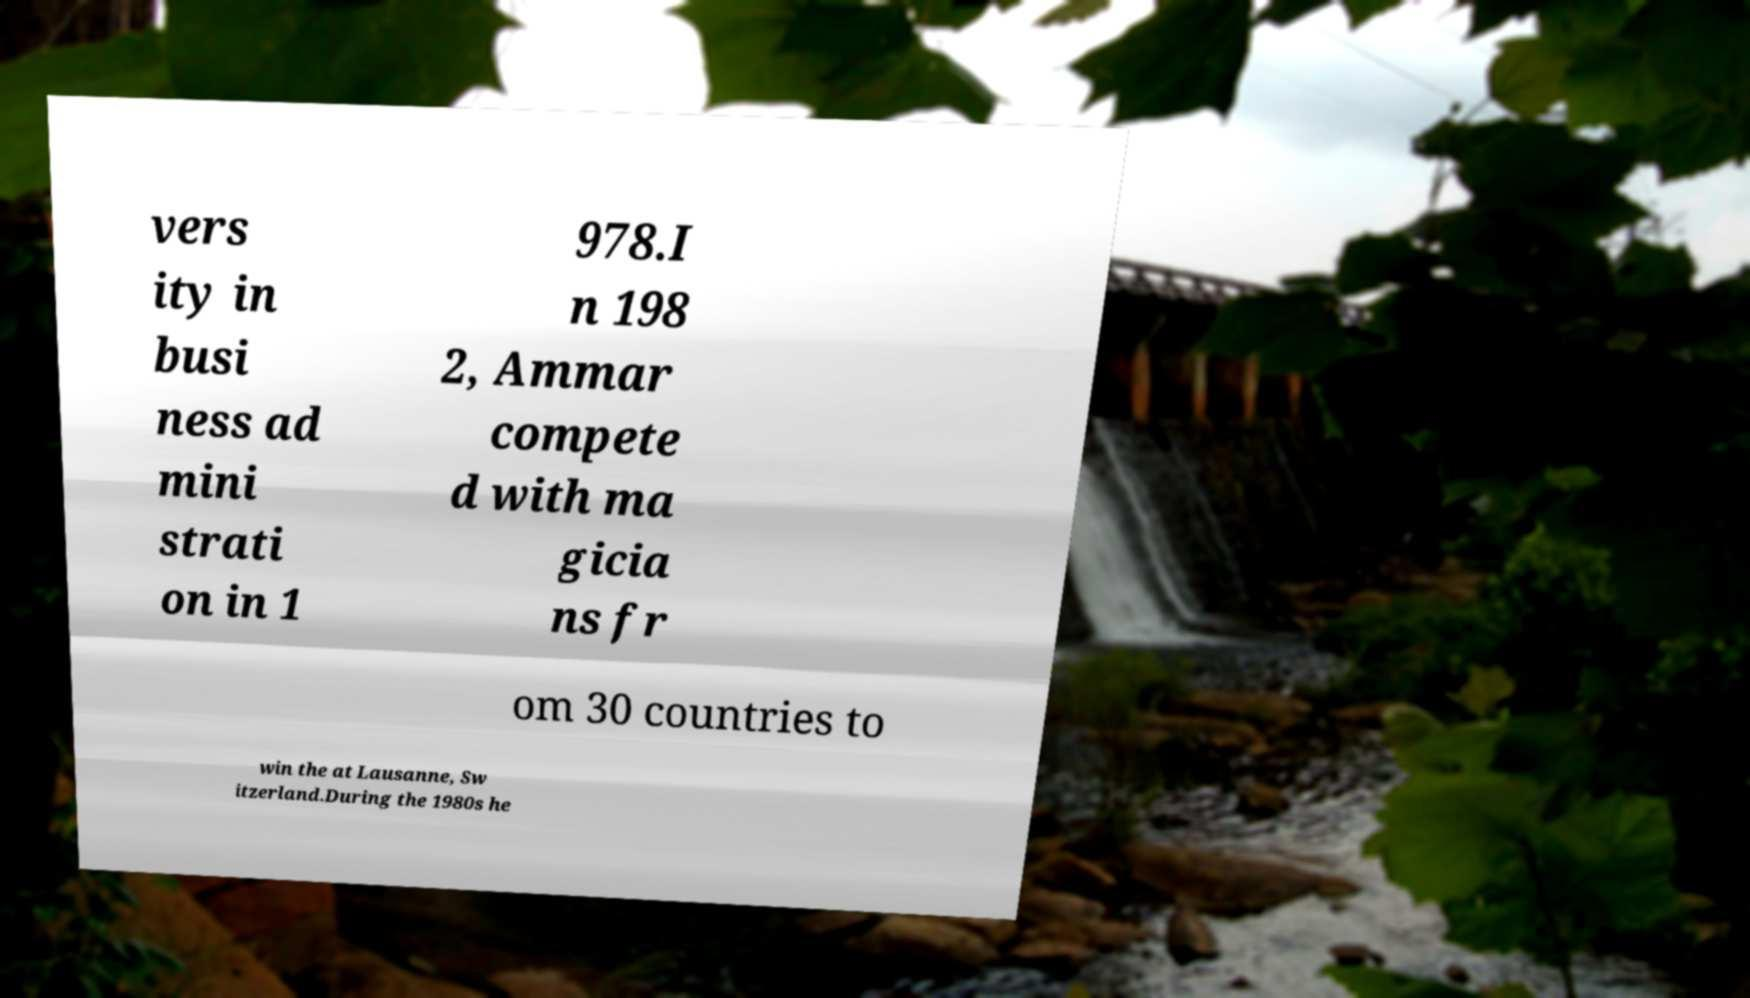Can you accurately transcribe the text from the provided image for me? vers ity in busi ness ad mini strati on in 1 978.I n 198 2, Ammar compete d with ma gicia ns fr om 30 countries to win the at Lausanne, Sw itzerland.During the 1980s he 